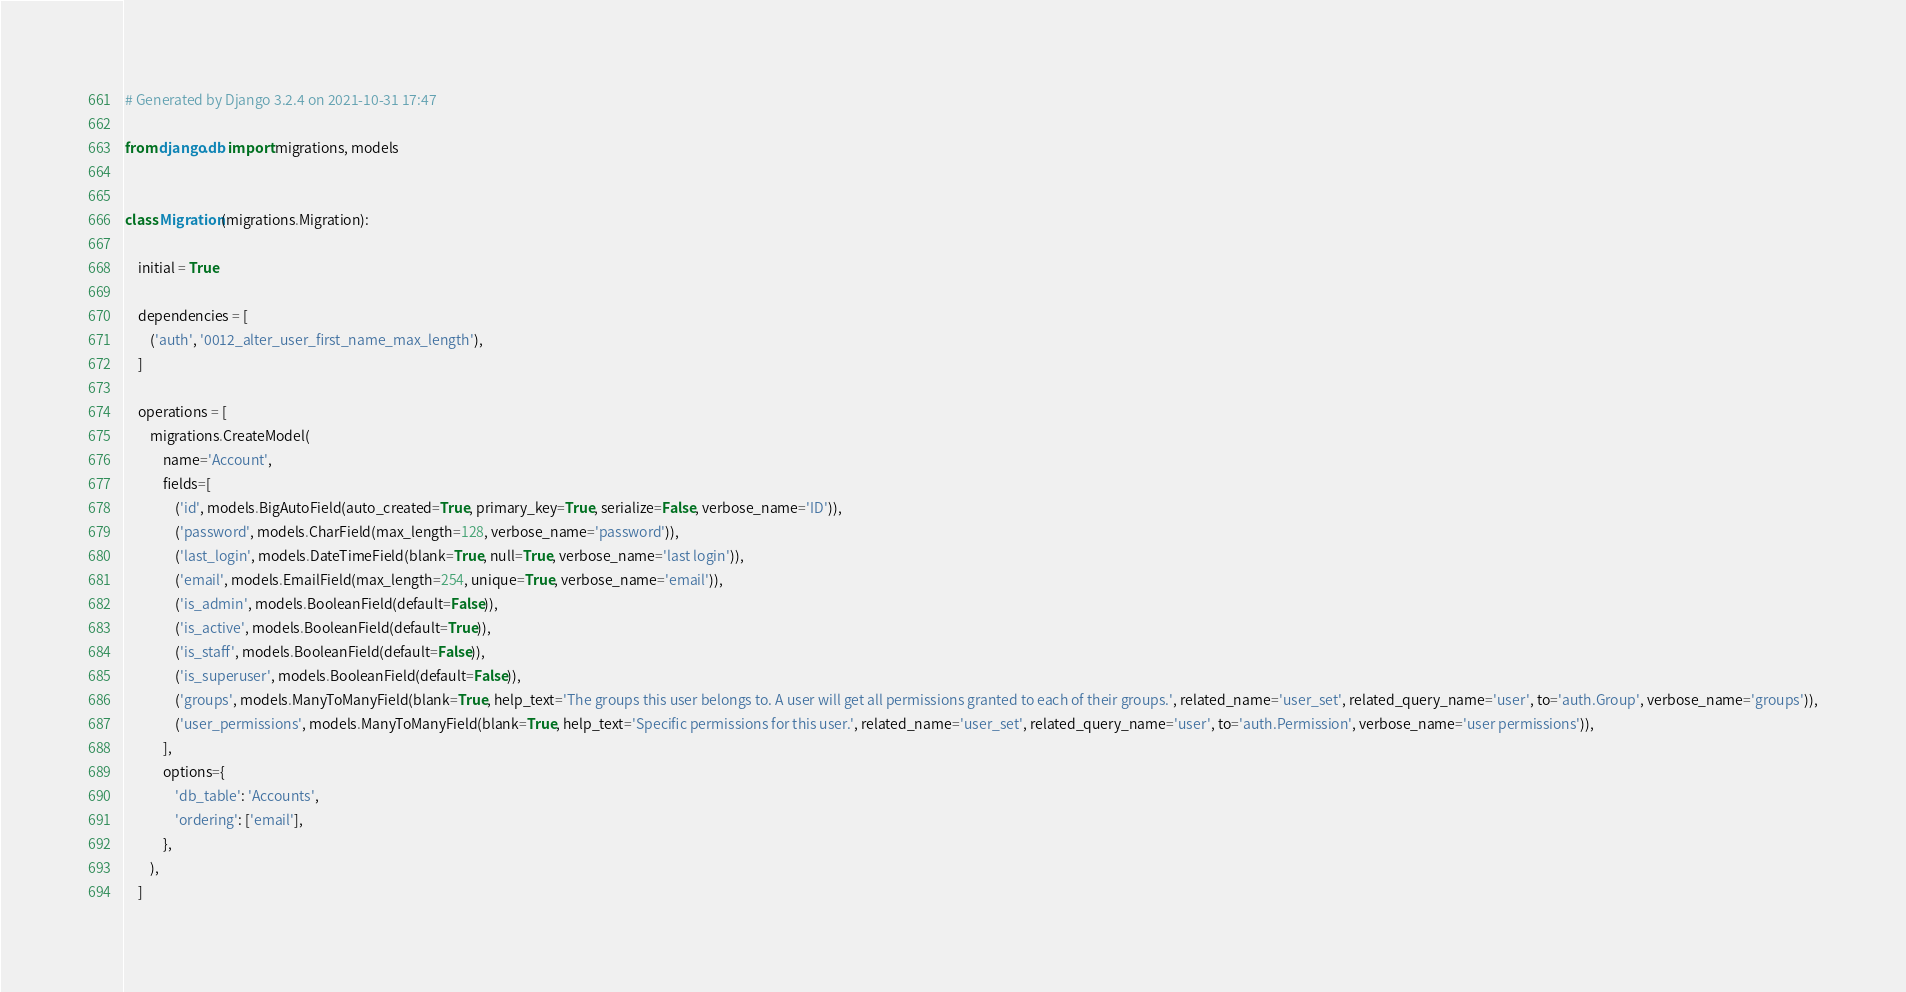<code> <loc_0><loc_0><loc_500><loc_500><_Python_># Generated by Django 3.2.4 on 2021-10-31 17:47

from django.db import migrations, models


class Migration(migrations.Migration):

    initial = True

    dependencies = [
        ('auth', '0012_alter_user_first_name_max_length'),
    ]

    operations = [
        migrations.CreateModel(
            name='Account',
            fields=[
                ('id', models.BigAutoField(auto_created=True, primary_key=True, serialize=False, verbose_name='ID')),
                ('password', models.CharField(max_length=128, verbose_name='password')),
                ('last_login', models.DateTimeField(blank=True, null=True, verbose_name='last login')),
                ('email', models.EmailField(max_length=254, unique=True, verbose_name='email')),
                ('is_admin', models.BooleanField(default=False)),
                ('is_active', models.BooleanField(default=True)),
                ('is_staff', models.BooleanField(default=False)),
                ('is_superuser', models.BooleanField(default=False)),
                ('groups', models.ManyToManyField(blank=True, help_text='The groups this user belongs to. A user will get all permissions granted to each of their groups.', related_name='user_set', related_query_name='user', to='auth.Group', verbose_name='groups')),
                ('user_permissions', models.ManyToManyField(blank=True, help_text='Specific permissions for this user.', related_name='user_set', related_query_name='user', to='auth.Permission', verbose_name='user permissions')),
            ],
            options={
                'db_table': 'Accounts',
                'ordering': ['email'],
            },
        ),
    ]
</code> 